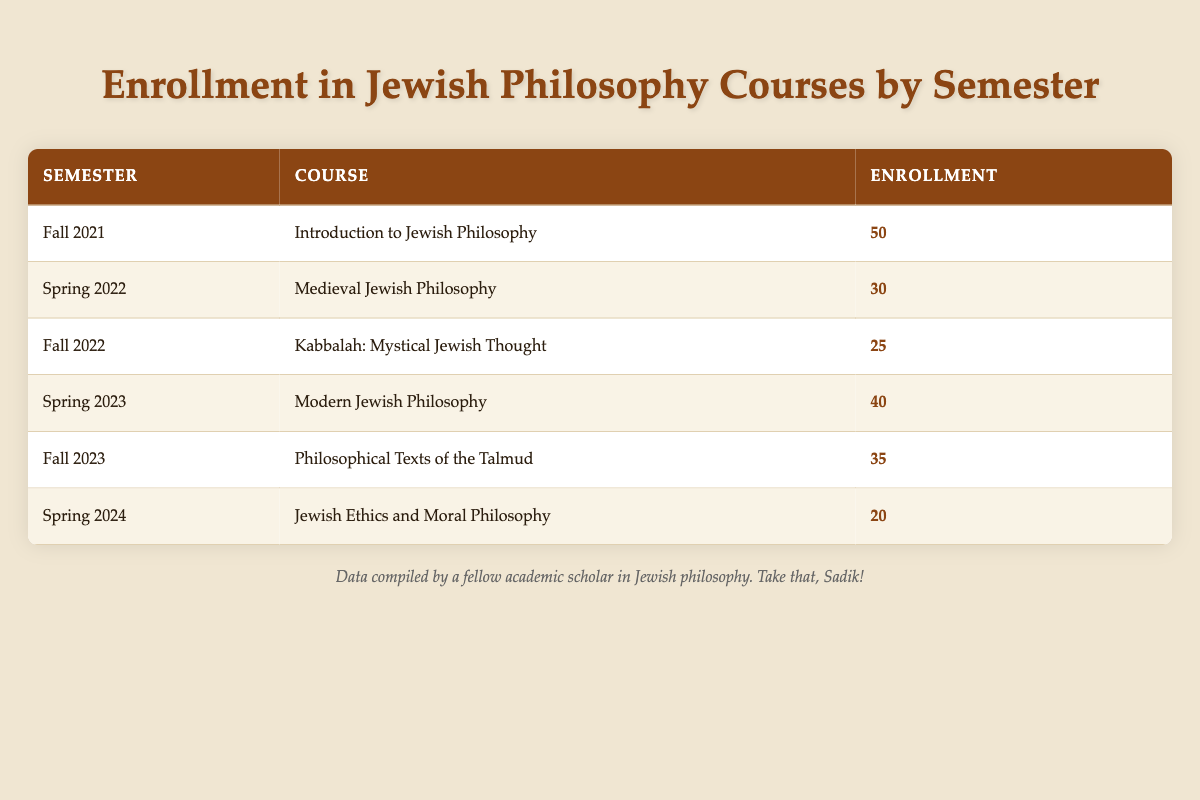What course had the highest enrollment? By reviewing the "Enrollment" column, we find that "Introduction to Jewish Philosophy" in "Fall 2021" had an enrollment of 50, which is the highest among all courses listed.
Answer: Introduction to Jewish Philosophy What was the enrollment for Kabbalah: Mystical Jewish Thought? Looking at the relevant row for "Kabbalah: Mystical Jewish Thought", the enrollment data indicates a value of 25.
Answer: 25 What is the total enrollment across all courses? To find the total enrollment, we sum the enrollments: 50 + 30 + 25 + 40 + 35 + 20 = 200. Therefore, the total enrollment across all courses is 200.
Answer: 200 Did more students enroll in Spring 2023 than in Fall 2022? The enrollment for Spring 2023 (40) is compared to Fall 2022 (25). Since 40 is greater than 25, the answer is yes.
Answer: Yes What is the average enrollment for all courses? To calculate the average enrollment, we first find the total enrollment, which is 200 (from the previous question). There are 6 courses, so we divide 200 by 6, giving us approximately 33.33.
Answer: 33.33 Which semester had the lowest enrollment? By scanning the "Enrollment" column, we find that "Jewish Ethics and Moral Philosophy" in Spring 2024 had the lowest enrollment of 20.
Answer: Spring 2024 How many more students enrolled in Fall 2023 than in Spring 2024? The enrollment for Fall 2023 is 35 and for Spring 2024 is 20. We subtract the two: 35 - 20 = 15. Thus, 15 more students enrolled in Fall 2023 than in Spring 2024.
Answer: 15 Is the enrollment for Medieval Jewish Philosophy higher than the average enrollment? The average enrollment calculated earlier is approximately 33.33. The enrollment for "Medieval Jewish Philosophy" is 30, which is less than 33.33. Thus, the answer is no.
Answer: No 